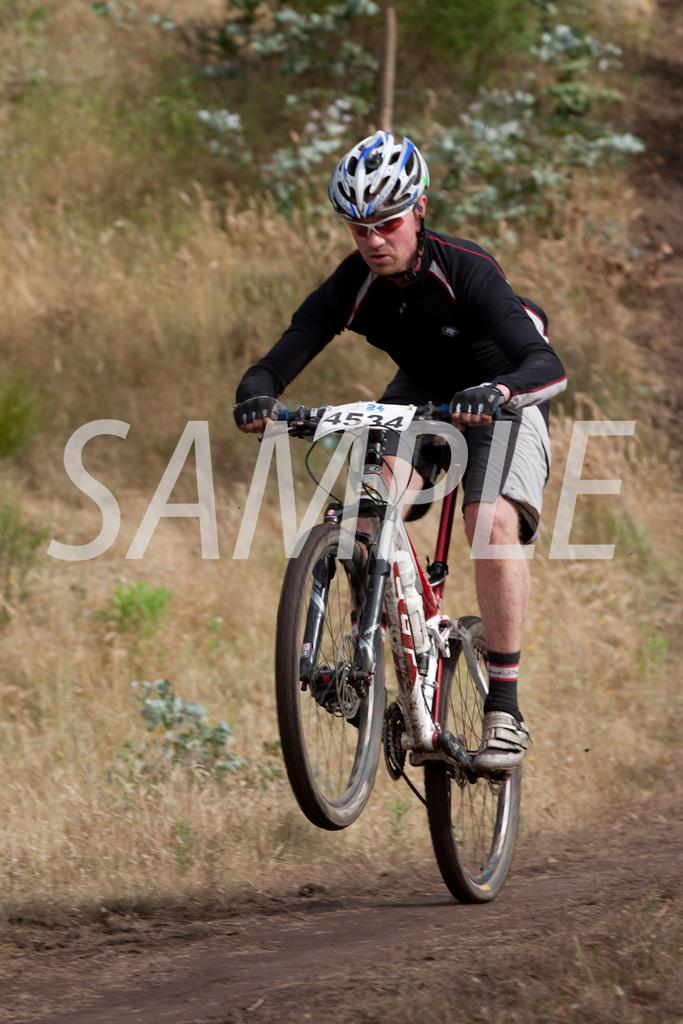Who is the person in the image? There is a man in the image. What is the man wearing on his head? The man is wearing a helmet. What is the man doing in the image? The man is riding a bicycle. What type of terrain can be seen in the image? There is grass visible in the image, and there are trees as well. What type of roof can be seen on the bicycle in the image? There is no roof present on the bicycle in the image. Does the existence of the man in the image prove the existence of extraterrestrial life? The presence of the man in the image does not prove the existence of extraterrestrial life, as the image only shows a man riding a bicycle. 